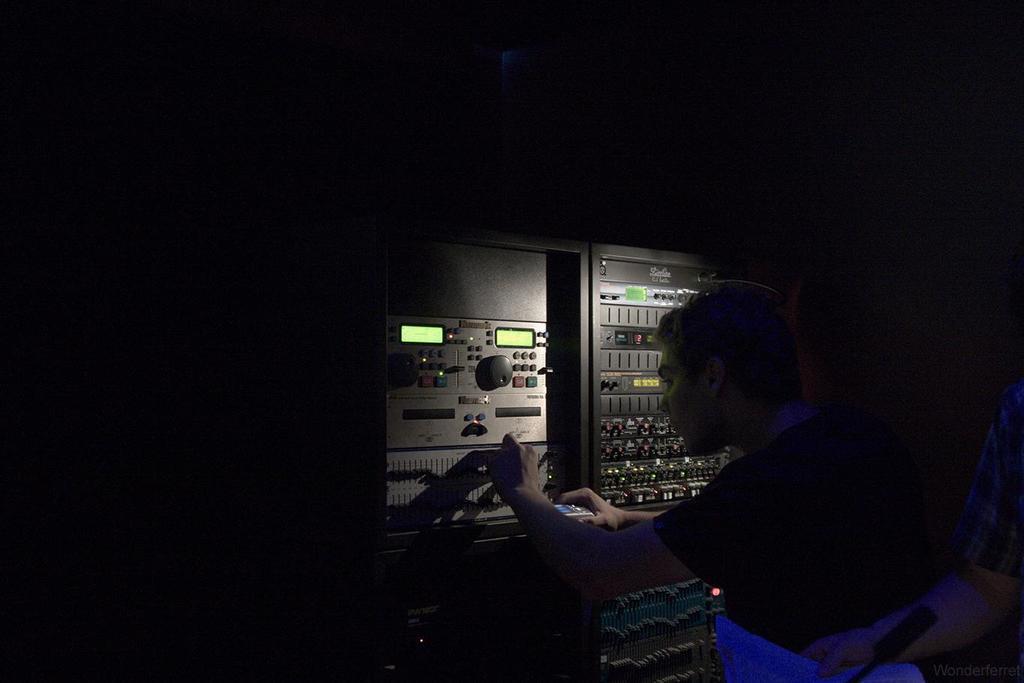Describe this image in one or two sentences. In this image, on the right side, we can see a man standing in front of a electrical machine. In the background, we can see black color. 